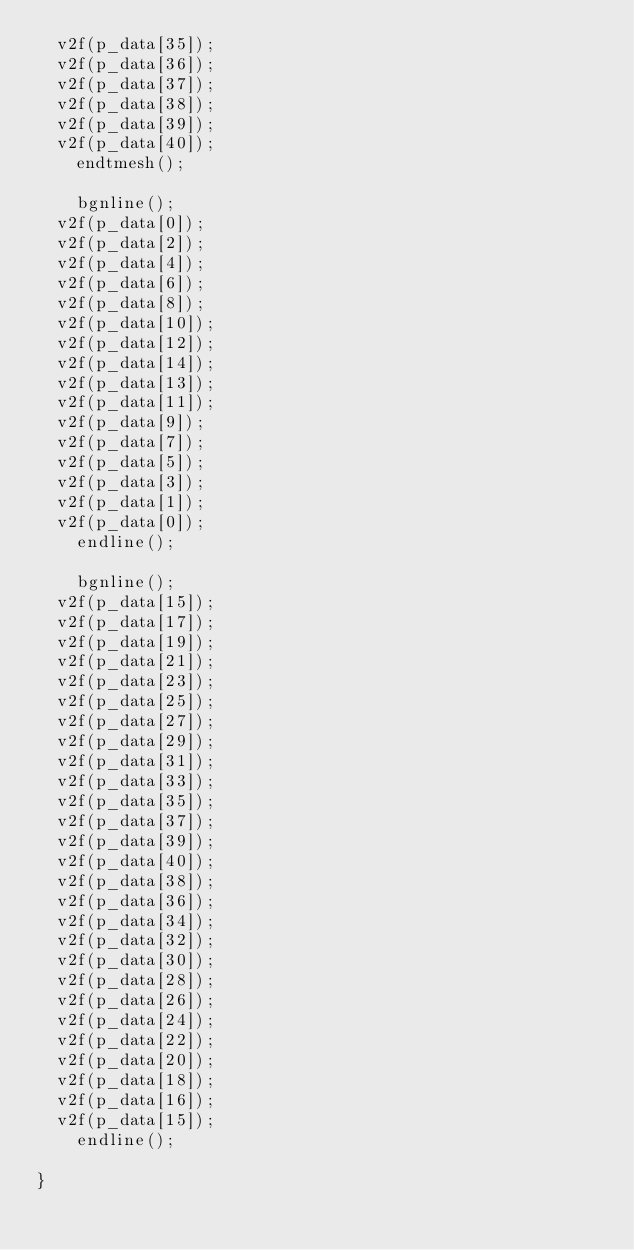<code> <loc_0><loc_0><loc_500><loc_500><_C_>	v2f(p_data[35]);
	v2f(p_data[36]);
	v2f(p_data[37]);
	v2f(p_data[38]);
	v2f(p_data[39]);
	v2f(p_data[40]);
    endtmesh();

    bgnline();
	v2f(p_data[0]);
	v2f(p_data[2]);
	v2f(p_data[4]);
	v2f(p_data[6]);
	v2f(p_data[8]);
	v2f(p_data[10]);
	v2f(p_data[12]);
	v2f(p_data[14]);
	v2f(p_data[13]);
	v2f(p_data[11]);
	v2f(p_data[9]);
	v2f(p_data[7]);
	v2f(p_data[5]);
	v2f(p_data[3]);
	v2f(p_data[1]);
	v2f(p_data[0]);
    endline();

    bgnline();
	v2f(p_data[15]);
	v2f(p_data[17]);
	v2f(p_data[19]);
	v2f(p_data[21]);
	v2f(p_data[23]);
	v2f(p_data[25]);
	v2f(p_data[27]);
	v2f(p_data[29]);
	v2f(p_data[31]);
	v2f(p_data[33]);
	v2f(p_data[35]);
	v2f(p_data[37]);
	v2f(p_data[39]);
	v2f(p_data[40]);
	v2f(p_data[38]);
	v2f(p_data[36]);
	v2f(p_data[34]);
	v2f(p_data[32]);
	v2f(p_data[30]);
	v2f(p_data[28]);
	v2f(p_data[26]);
	v2f(p_data[24]);
	v2f(p_data[22]);
	v2f(p_data[20]);
	v2f(p_data[18]);
	v2f(p_data[16]);
	v2f(p_data[15]);
    endline();

}

</code> 